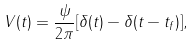<formula> <loc_0><loc_0><loc_500><loc_500>V ( t ) = \frac { \psi } { 2 \pi } [ \delta ( t ) - \delta ( t - t _ { f } ) ] ,</formula> 